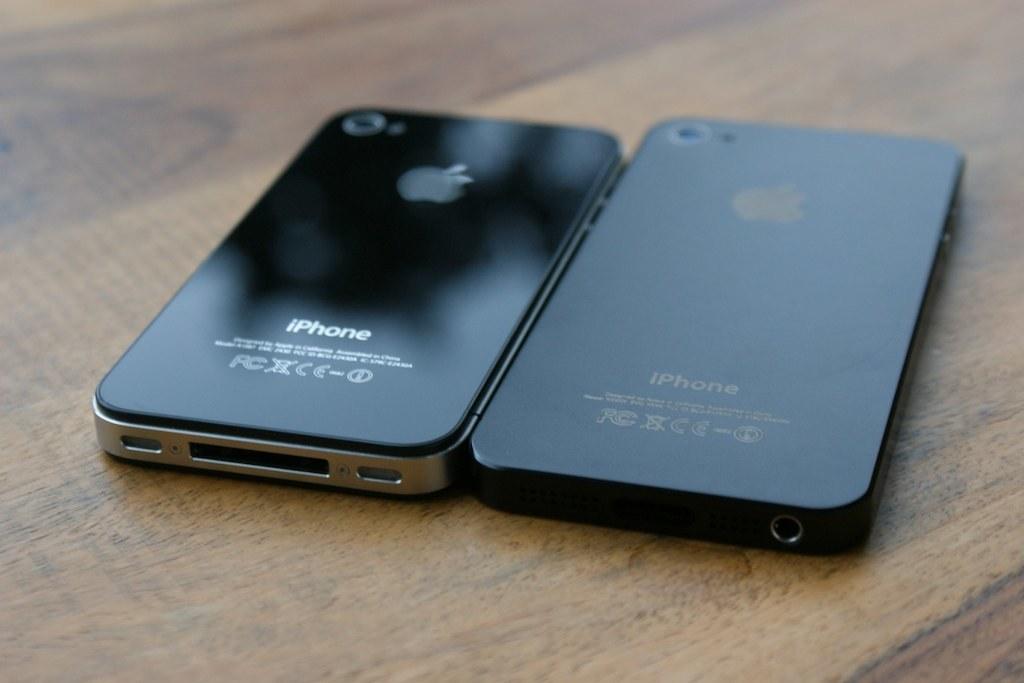What make are the phones?
Your answer should be very brief. Iphone. 